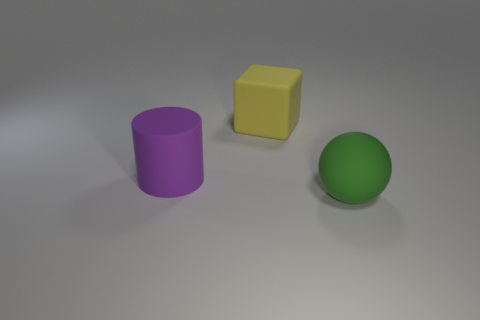Add 3 yellow matte things. How many objects exist? 6 Subtract all cubes. How many objects are left? 2 Subtract all purple matte cylinders. Subtract all purple things. How many objects are left? 1 Add 1 purple things. How many purple things are left? 2 Add 3 big brown matte cylinders. How many big brown matte cylinders exist? 3 Subtract 0 green cylinders. How many objects are left? 3 